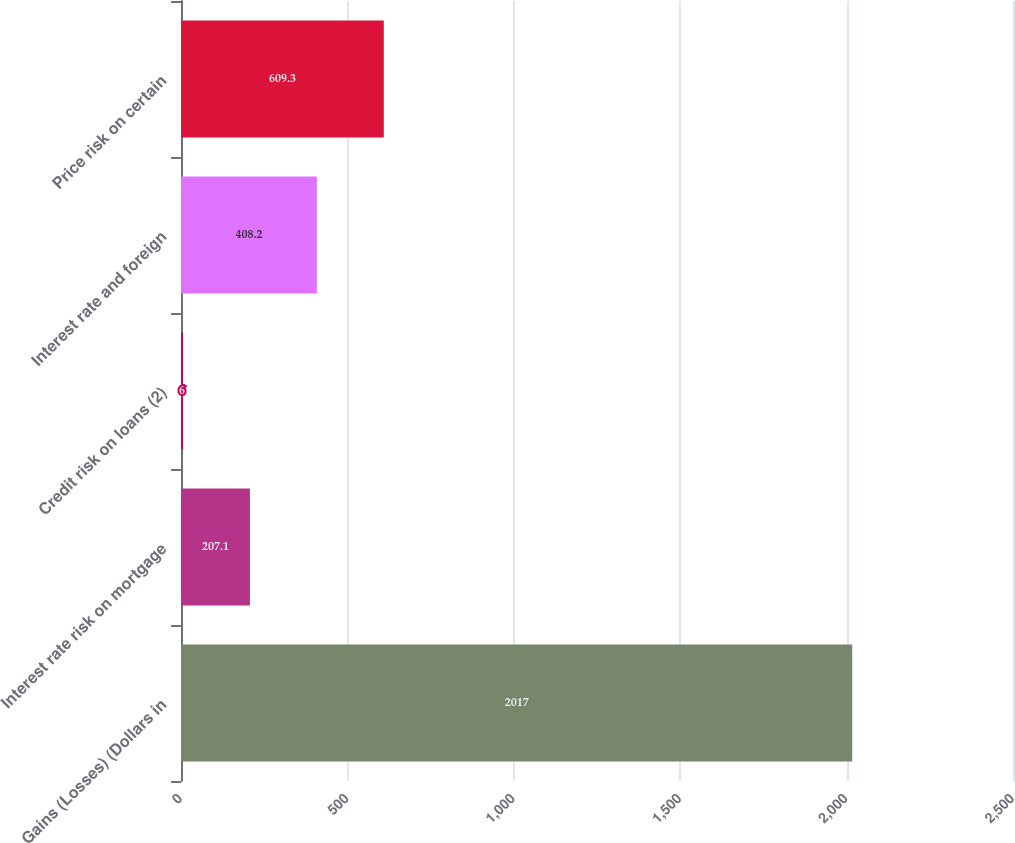<chart> <loc_0><loc_0><loc_500><loc_500><bar_chart><fcel>Gains (Losses) (Dollars in<fcel>Interest rate risk on mortgage<fcel>Credit risk on loans (2)<fcel>Interest rate and foreign<fcel>Price risk on certain<nl><fcel>2017<fcel>207.1<fcel>6<fcel>408.2<fcel>609.3<nl></chart> 